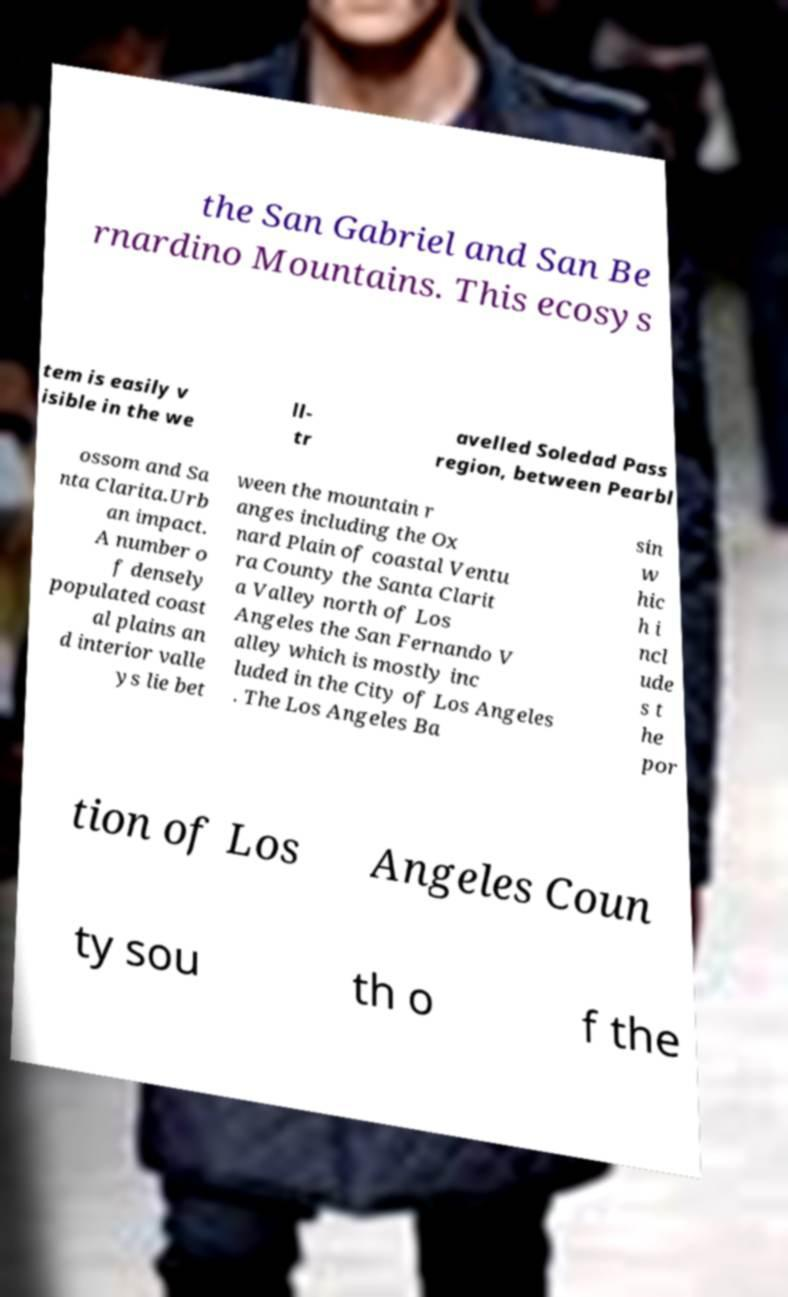Please read and relay the text visible in this image. What does it say? the San Gabriel and San Be rnardino Mountains. This ecosys tem is easily v isible in the we ll- tr avelled Soledad Pass region, between Pearbl ossom and Sa nta Clarita.Urb an impact. A number o f densely populated coast al plains an d interior valle ys lie bet ween the mountain r anges including the Ox nard Plain of coastal Ventu ra County the Santa Clarit a Valley north of Los Angeles the San Fernando V alley which is mostly inc luded in the City of Los Angeles . The Los Angeles Ba sin w hic h i ncl ude s t he por tion of Los Angeles Coun ty sou th o f the 